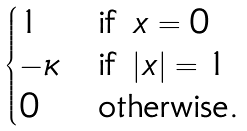<formula> <loc_0><loc_0><loc_500><loc_500>\begin{cases} 1 & \text {if } x = 0 \\ - \kappa & \text {if } | x | = 1 \\ 0 & \text {otherwise.} \end{cases}</formula> 